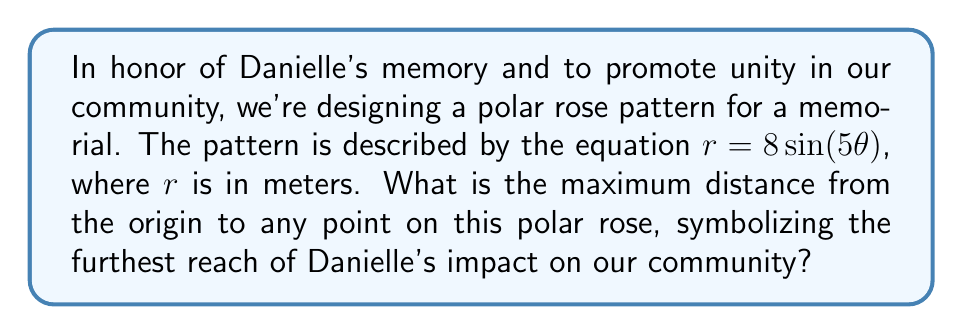Show me your answer to this math problem. To find the maximum distance from the origin in this polar rose pattern, we need to follow these steps:

1) The general equation for a polar rose is $r = a\sin(n\theta)$ or $r = a\cos(n\theta)$, where $a$ is the amplitude and $n$ is the number of petals.

2) In this case, we have $r = 8\sin(5\theta)$, so $a = 8$ and $n = 5$.

3) The maximum value of $\sin(5\theta)$ is 1, which occurs when $5\theta = 90°, 450°, 810°,$ etc., or when $\theta = 18°, 90°, 162°,$ etc.

4) When $\sin(5\theta) = 1$, $r$ will be at its maximum value.

5) Therefore, the maximum value of $r$ is equal to $a$, which is 8 meters.

This maximum distance represents the furthest reach of Danielle's impact, symbolizing how her story has touched even those at the edges of our community.

[asy]
import graph;
size(200);
real r(real t) {return 8*sin(5*t);}
draw(polargraph(r,0,2*pi),blue);
dot((8,0),red);
label("8m",(8,0),E,red);
[/asy]
Answer: The maximum distance from the origin in the polar rose pattern is 8 meters. 